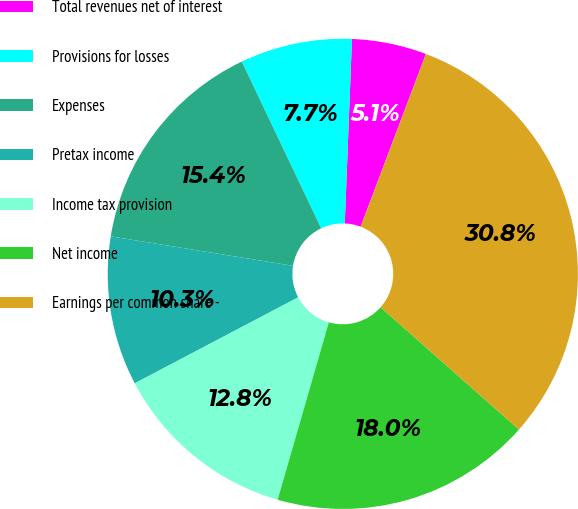<chart> <loc_0><loc_0><loc_500><loc_500><pie_chart><fcel>Total revenues net of interest<fcel>Provisions for losses<fcel>Expenses<fcel>Pretax income<fcel>Income tax provision<fcel>Net income<fcel>Earnings per common share -<nl><fcel>5.13%<fcel>7.69%<fcel>15.38%<fcel>10.26%<fcel>12.82%<fcel>17.95%<fcel>30.77%<nl></chart> 